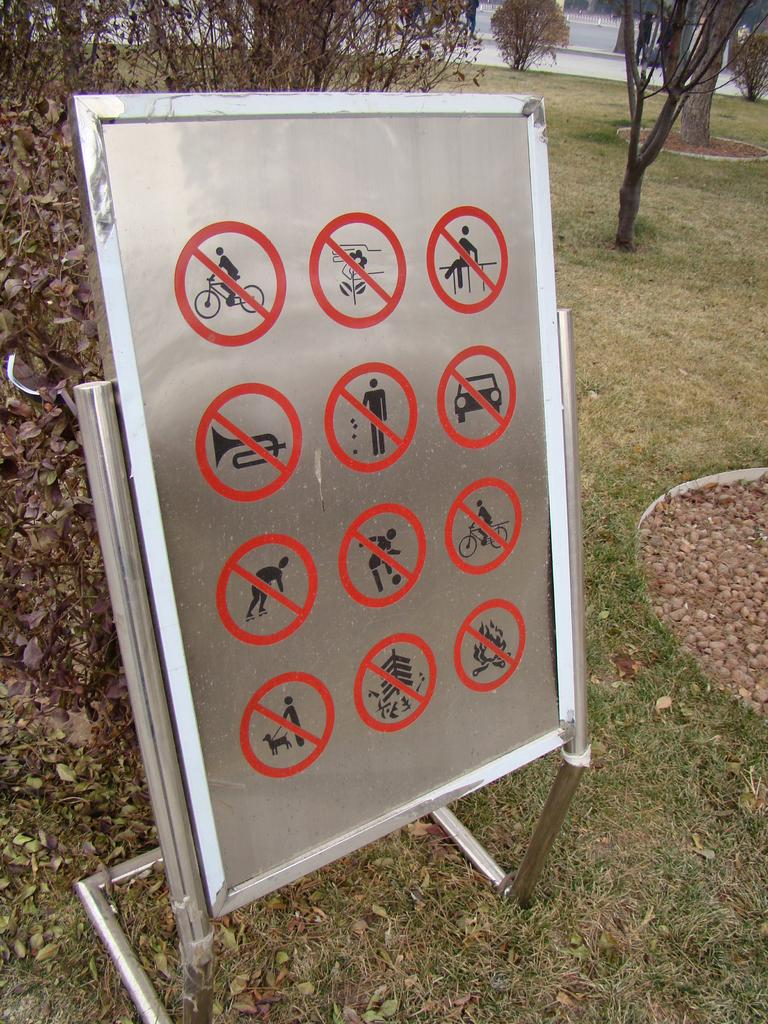What is on the board that is visible in the image? There are signs on the board in the image. How is the board with signs positioned in the image? The board is placed on a stand, and the stand is on the ground. What can be seen in the background of the image? There is a group of trees and grass in the background of the image. How many apples are hanging from the trees in the image? There are no apples visible in the image; only trees and grass are present in the background. 